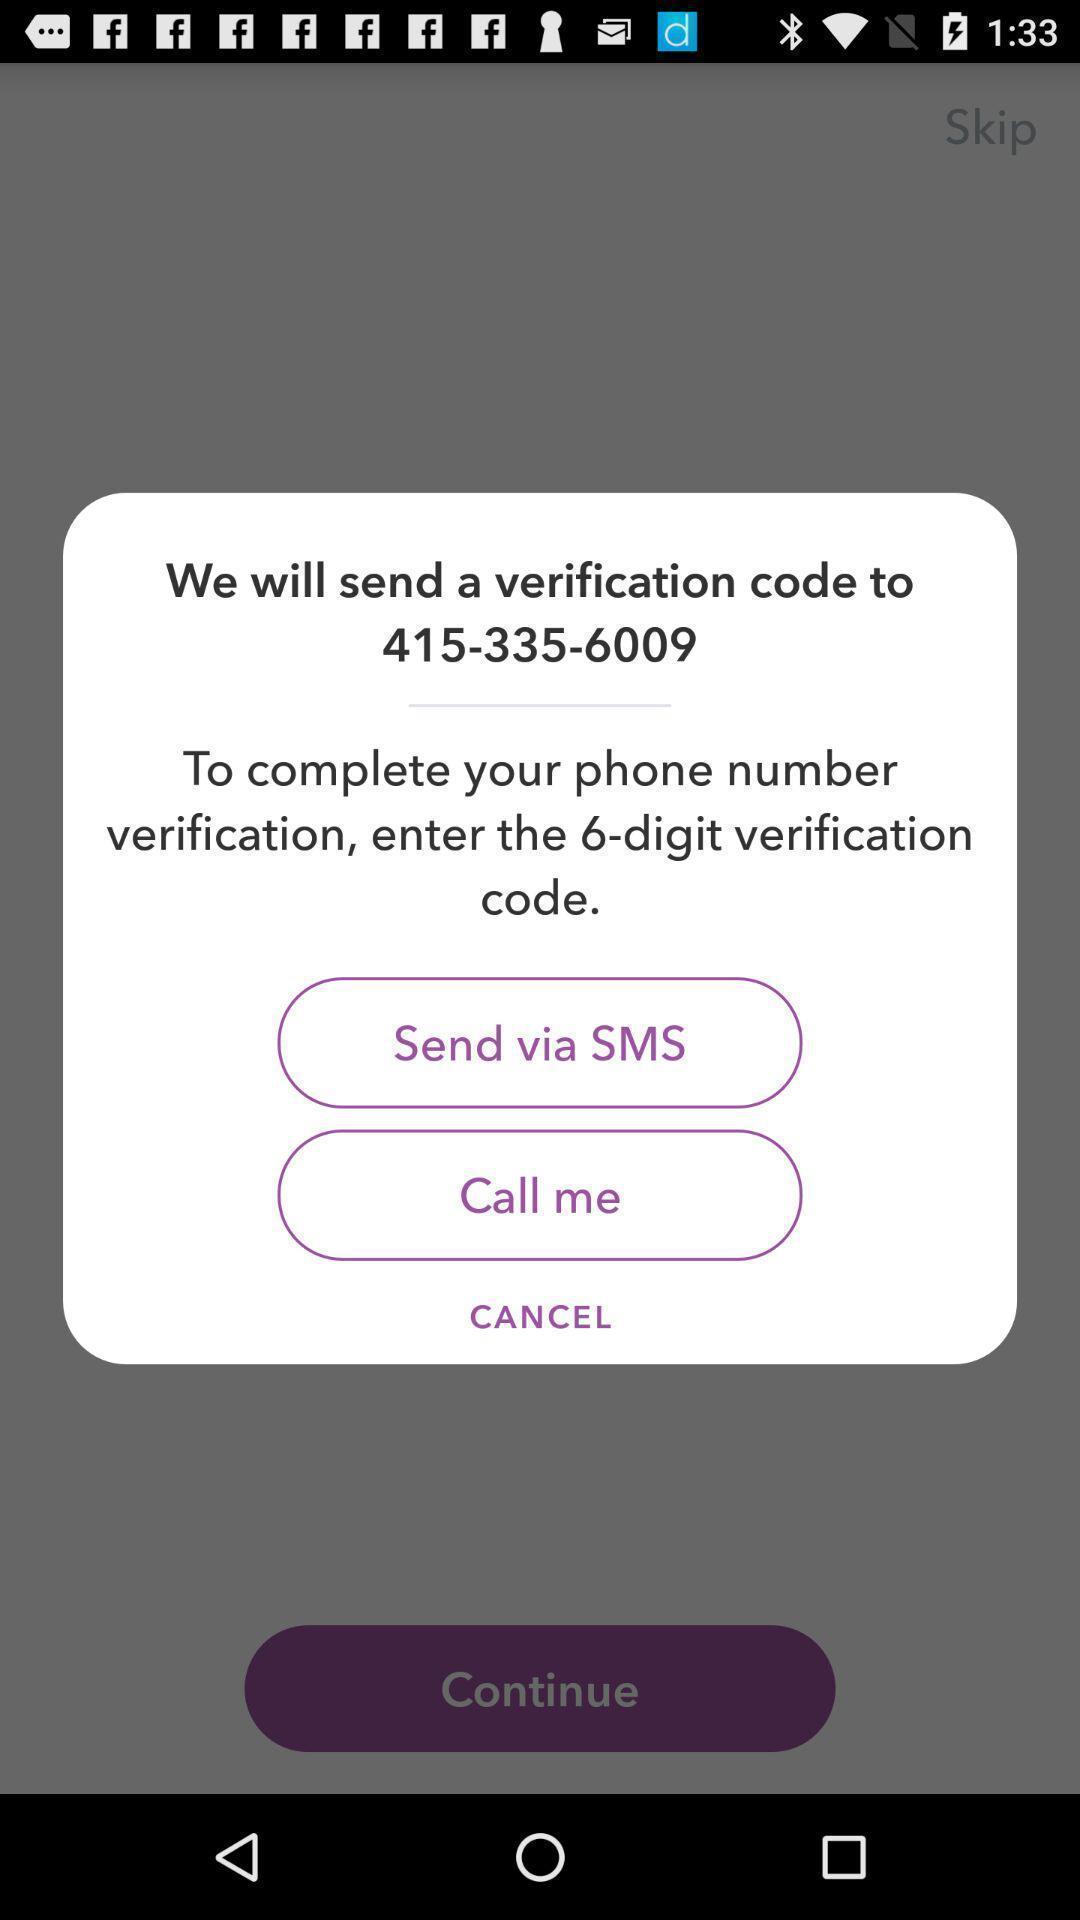Provide a description of this screenshot. Popup to verify via different options in the application. 